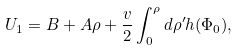Convert formula to latex. <formula><loc_0><loc_0><loc_500><loc_500>U _ { 1 } = B + A \rho + \frac { v } { 2 } \int _ { 0 } ^ { \rho } d \rho ^ { \prime } h ( \Phi _ { 0 } ) ,</formula> 